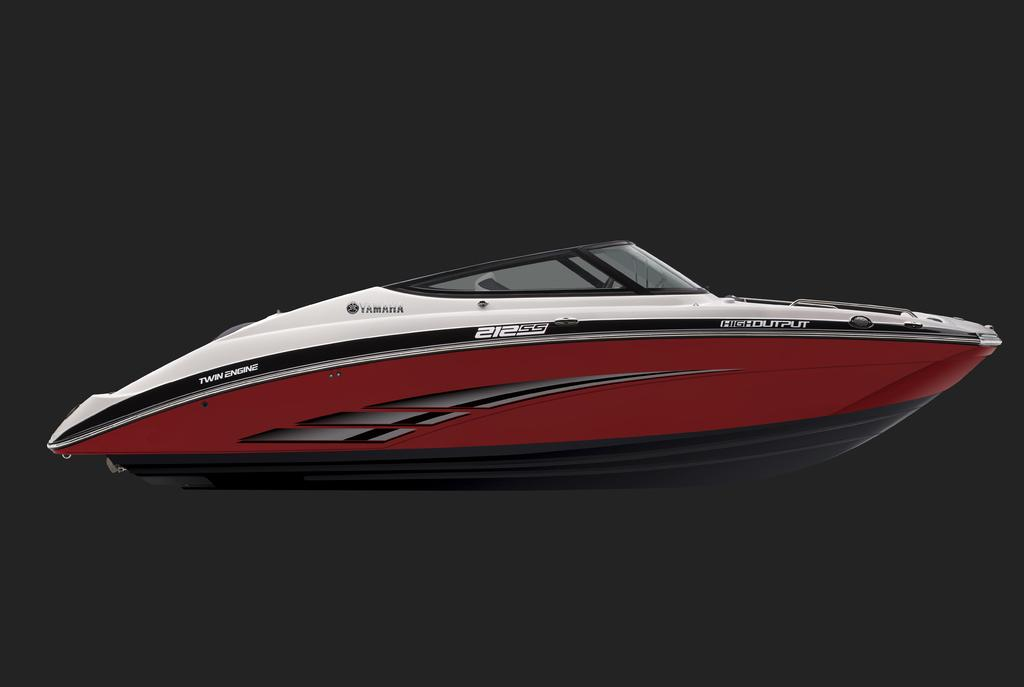What is the main subject of the image? The main subject of the image is a boat. Are there any specific features on the boat? Yes, the boat has names on it and glass windows. What can be observed about the background of the image? The background of the image is dark. Can you tell me how many brains are visible in the image? There are no brains present in the image; it features a boat with names and glass windows against a dark background. What type of discussion is taking place in the image? There is no discussion taking place in the image; it only shows a boat with specific features and a dark background. 